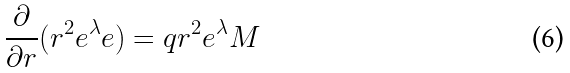Convert formula to latex. <formula><loc_0><loc_0><loc_500><loc_500>\frac { \partial } { \partial r } ( r ^ { 2 } e ^ { \lambda } e ) = q r ^ { 2 } e ^ { \lambda } M</formula> 